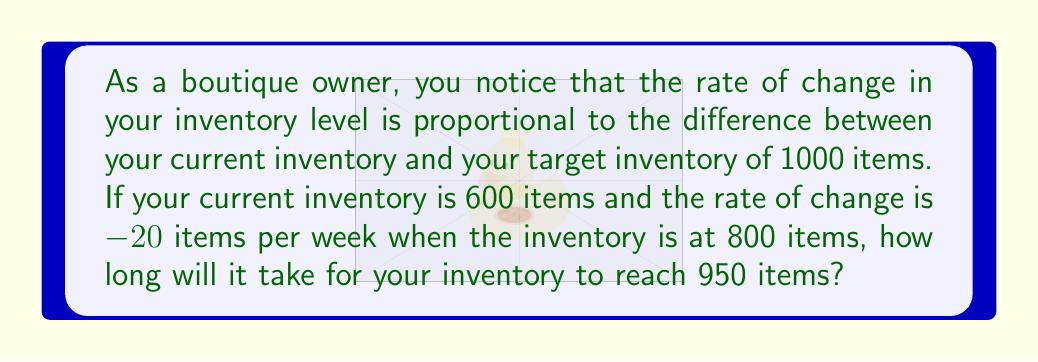Can you answer this question? Let's approach this step-by-step using a differential equation:

1) Let $I(t)$ be the inventory level at time $t$ (in weeks).

2) The given information can be modeled by the differential equation:

   $$\frac{dI}{dt} = k(1000 - I)$$

   where $k$ is a constant of proportionality.

3) We're given that when $I = 800$, $\frac{dI}{dt} = -20$. Let's use this to find $k$:

   $$-20 = k(1000 - 800)$$
   $$-20 = 200k$$
   $$k = -0.1$$

4) Now our differential equation is:

   $$\frac{dI}{dt} = -0.1(1000 - I)$$

5) This is a separable differential equation. Let's solve it:

   $$\frac{dI}{1000 - I} = -0.1dt$$

6) Integrating both sides:

   $$-\ln|1000 - I| = -0.1t + C$$

7) Using the initial condition $I(0) = 600$:

   $$-\ln|1000 - 600| = C$$
   $$C = -\ln(400) = -5.991$$

8) Therefore, the general solution is:

   $$\ln|1000 - I| = 0.1t + 5.991$$

9) We want to find $t$ when $I = 950$. Substituting:

   $$\ln|1000 - 950| = 0.1t + 5.991$$
   $$\ln(50) = 0.1t + 5.991$$
   $$3.912 = 0.1t + 5.991$$
   $$-2.079 = 0.1t$$
   $$t = -20.79$$

10) Since time can't be negative, we take the absolute value.
Answer: 20.79 weeks 